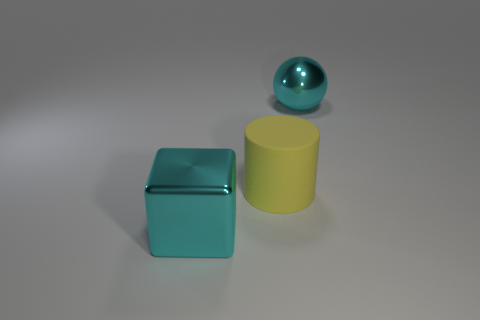Are there any other things that are made of the same material as the yellow cylinder?
Give a very brief answer. No. The metal thing that is the same color as the metallic cube is what shape?
Offer a terse response. Sphere. Is the color of the shiny thing that is to the left of the large ball the same as the large shiny thing right of the metal cube?
Provide a succinct answer. Yes. What size is the cube that is the same color as the ball?
Provide a succinct answer. Large. Are the large thing that is behind the large yellow rubber cylinder and the cube made of the same material?
Make the answer very short. Yes. What number of other things are there of the same shape as the yellow matte thing?
Your response must be concise. 0. There is a big cyan metallic thing right of the shiny object in front of the big ball; how many cyan metal things are in front of it?
Keep it short and to the point. 1. What color is the big shiny object in front of the large cyan metallic sphere?
Provide a succinct answer. Cyan. Do the metal thing left of the large yellow cylinder and the large ball have the same color?
Your answer should be compact. Yes. There is a cyan object that is behind the metallic object on the left side of the cyan object behind the cyan metallic block; what is its material?
Provide a short and direct response. Metal. 